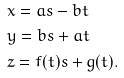Convert formula to latex. <formula><loc_0><loc_0><loc_500><loc_500>& x = a s - b t & \\ & y = b s + a t & \\ & z = f ( t ) s + g ( t ) . &</formula> 